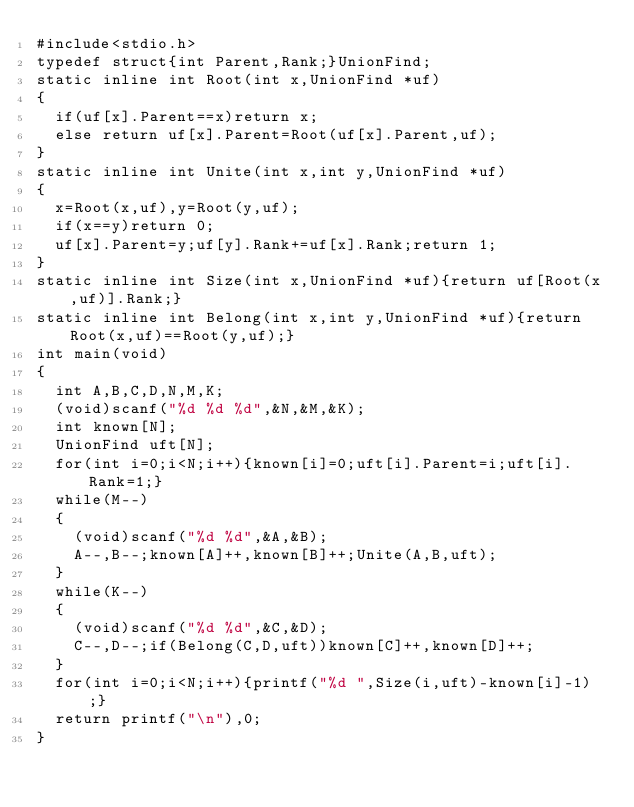Convert code to text. <code><loc_0><loc_0><loc_500><loc_500><_C_>#include<stdio.h>
typedef struct{int Parent,Rank;}UnionFind;
static inline int Root(int x,UnionFind *uf)
{
  if(uf[x].Parent==x)return x;
  else return uf[x].Parent=Root(uf[x].Parent,uf);
}
static inline int Unite(int x,int y,UnionFind *uf)
{
  x=Root(x,uf),y=Root(y,uf);
  if(x==y)return 0;
  uf[x].Parent=y;uf[y].Rank+=uf[x].Rank;return 1;
}
static inline int Size(int x,UnionFind *uf){return uf[Root(x,uf)].Rank;}
static inline int Belong(int x,int y,UnionFind *uf){return Root(x,uf)==Root(y,uf);}
int main(void)
{
  int A,B,C,D,N,M,K;
  (void)scanf("%d %d %d",&N,&M,&K);
  int known[N];
  UnionFind uft[N];
  for(int i=0;i<N;i++){known[i]=0;uft[i].Parent=i;uft[i].Rank=1;}
  while(M--)
  {
    (void)scanf("%d %d",&A,&B);
    A--,B--;known[A]++,known[B]++;Unite(A,B,uft);
  }
  while(K--)
  {
    (void)scanf("%d %d",&C,&D);
    C--,D--;if(Belong(C,D,uft))known[C]++,known[D]++;
  }
  for(int i=0;i<N;i++){printf("%d ",Size(i,uft)-known[i]-1);}
  return printf("\n"),0;
}</code> 